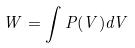Convert formula to latex. <formula><loc_0><loc_0><loc_500><loc_500>W = \int P ( V ) d V</formula> 